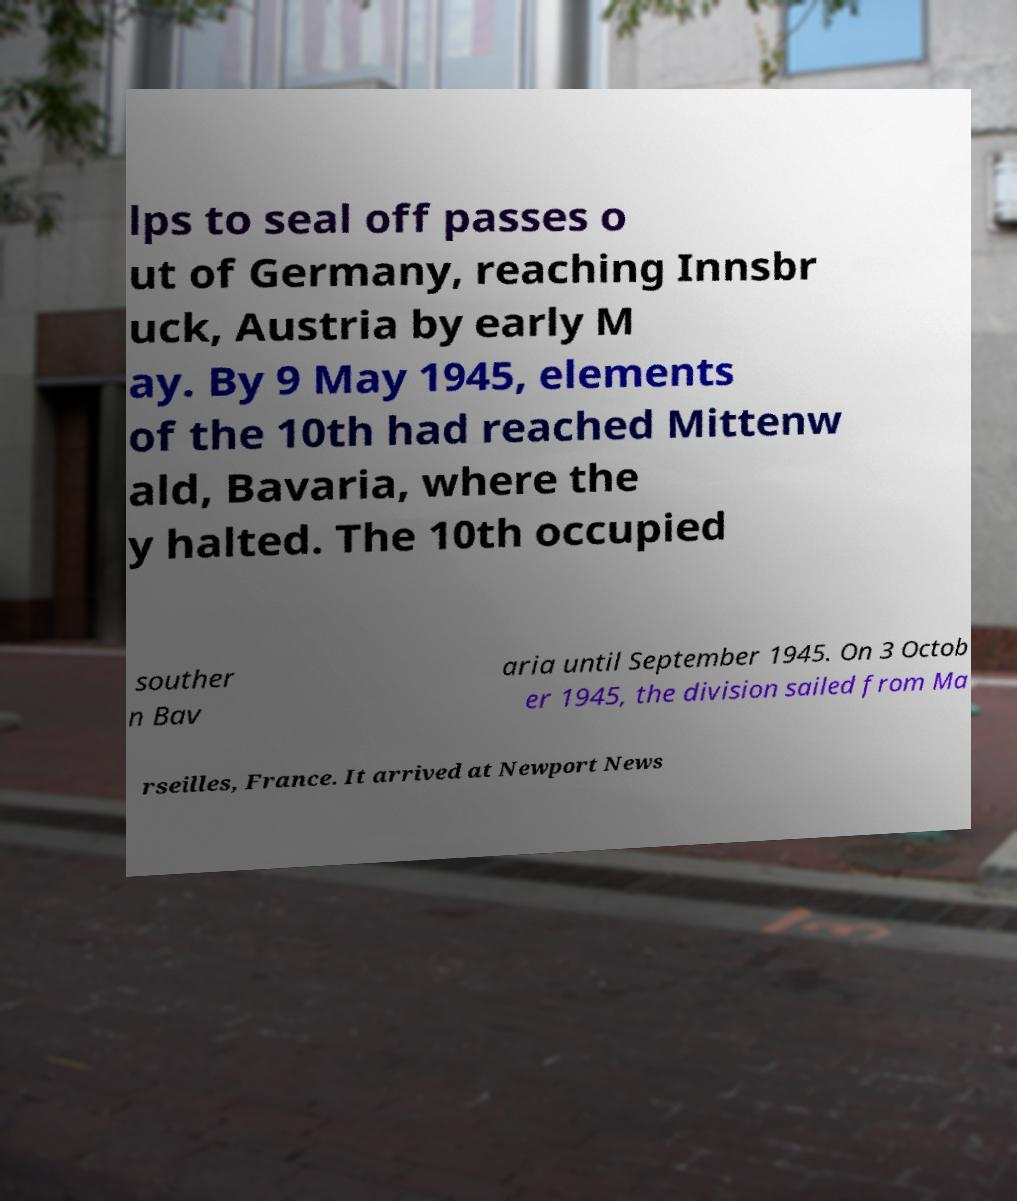Please identify and transcribe the text found in this image. lps to seal off passes o ut of Germany, reaching Innsbr uck, Austria by early M ay. By 9 May 1945, elements of the 10th had reached Mittenw ald, Bavaria, where the y halted. The 10th occupied souther n Bav aria until September 1945. On 3 Octob er 1945, the division sailed from Ma rseilles, France. It arrived at Newport News 